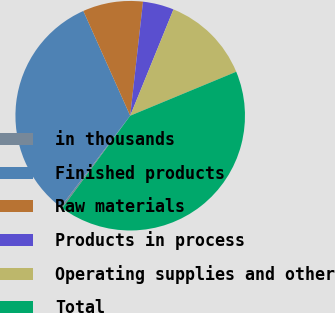Convert chart. <chart><loc_0><loc_0><loc_500><loc_500><pie_chart><fcel>in thousands<fcel>Finished products<fcel>Raw materials<fcel>Products in process<fcel>Operating supplies and other<fcel>Total<nl><fcel>0.26%<fcel>32.95%<fcel>8.48%<fcel>4.37%<fcel>12.59%<fcel>41.35%<nl></chart> 